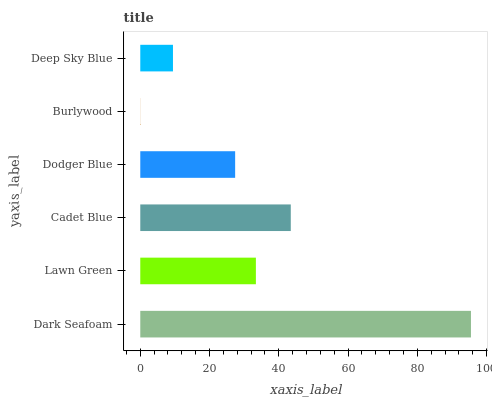Is Burlywood the minimum?
Answer yes or no. Yes. Is Dark Seafoam the maximum?
Answer yes or no. Yes. Is Lawn Green the minimum?
Answer yes or no. No. Is Lawn Green the maximum?
Answer yes or no. No. Is Dark Seafoam greater than Lawn Green?
Answer yes or no. Yes. Is Lawn Green less than Dark Seafoam?
Answer yes or no. Yes. Is Lawn Green greater than Dark Seafoam?
Answer yes or no. No. Is Dark Seafoam less than Lawn Green?
Answer yes or no. No. Is Lawn Green the high median?
Answer yes or no. Yes. Is Dodger Blue the low median?
Answer yes or no. Yes. Is Dark Seafoam the high median?
Answer yes or no. No. Is Dark Seafoam the low median?
Answer yes or no. No. 